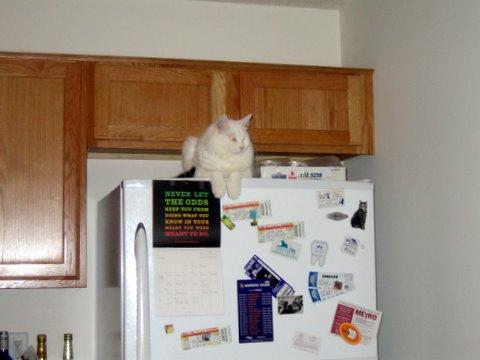What color is the cat?
Give a very brief answer. White. Is this a kitchen cabinet?
Write a very short answer. Yes. What is on top of the refrigerator?
Quick response, please. Cat. Do the people who live here like cats?
Be succinct. Yes. How many cats are there?
Concise answer only. 1. What is the cat laying on?
Concise answer only. Fridge. Where are the bottles?
Concise answer only. On counter. 